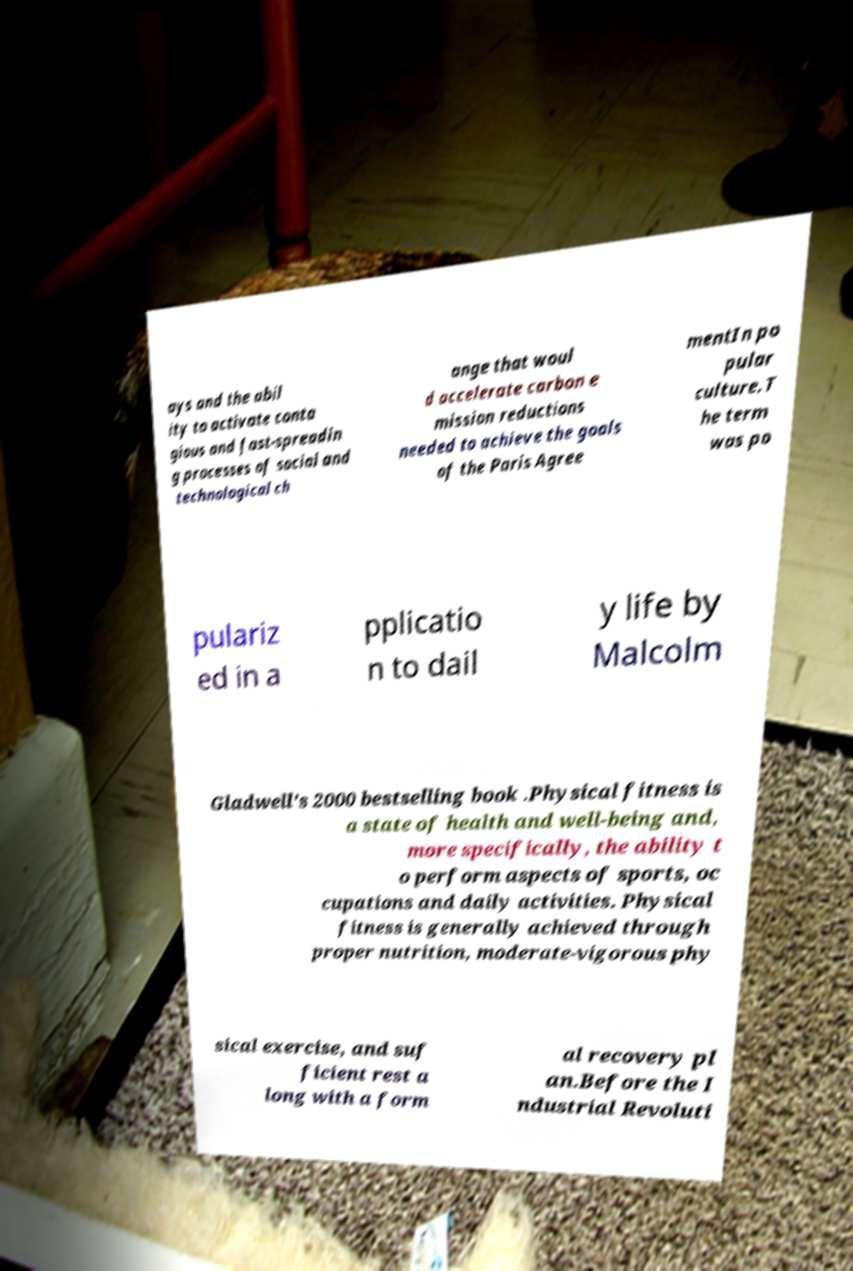Can you read and provide the text displayed in the image?This photo seems to have some interesting text. Can you extract and type it out for me? ays and the abil ity to activate conta gious and fast-spreadin g processes of social and technological ch ange that woul d accelerate carbon e mission reductions needed to achieve the goals of the Paris Agree mentIn po pular culture.T he term was po pulariz ed in a pplicatio n to dail y life by Malcolm Gladwell's 2000 bestselling book .Physical fitness is a state of health and well-being and, more specifically, the ability t o perform aspects of sports, oc cupations and daily activities. Physical fitness is generally achieved through proper nutrition, moderate-vigorous phy sical exercise, and suf ficient rest a long with a form al recovery pl an.Before the I ndustrial Revoluti 